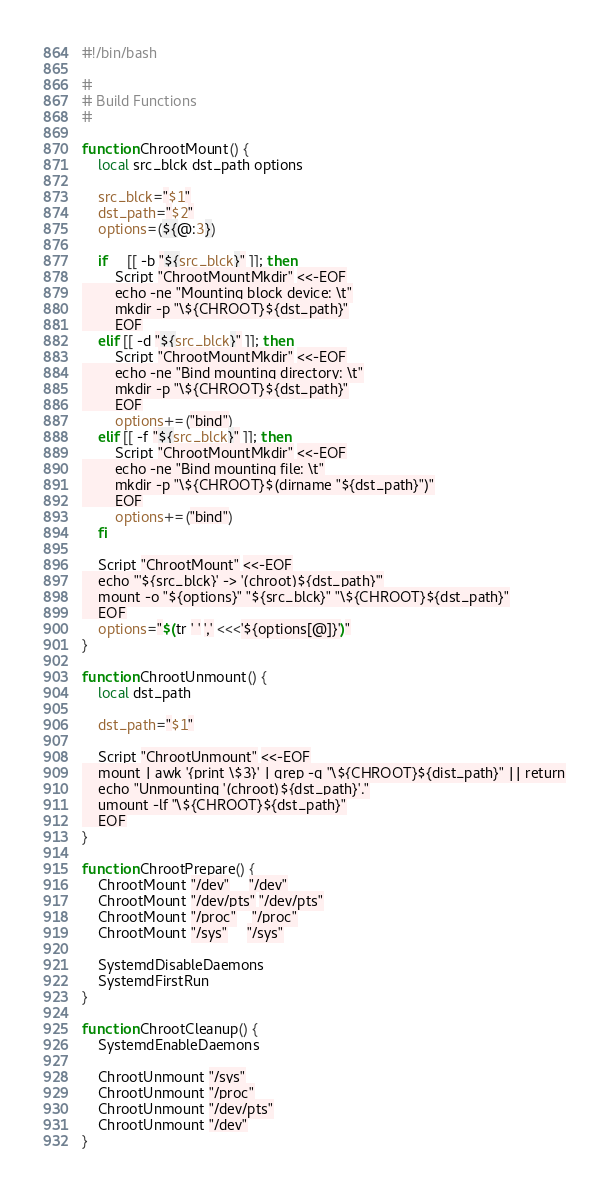<code> <loc_0><loc_0><loc_500><loc_500><_Bash_>#!/bin/bash

#
# Build Functions
#

function ChrootMount() {
	local src_blck dst_path options

	src_blck="$1"
	dst_path="$2"
	options=(${@:3})

	if	 [[ -b "${src_blck}" ]]; then
		Script "ChrootMountMkdir" <<-EOF
		echo -ne "Mounting block device: \t"
		mkdir -p "\${CHROOT}${dst_path}"
		EOF
	elif [[ -d "${src_blck}" ]]; then
		Script "ChrootMountMkdir" <<-EOF
		echo -ne "Bind mounting directory: \t"
		mkdir -p "\${CHROOT}${dst_path}"
		EOF
		options+=("bind")
	elif [[ -f "${src_blck}" ]]; then
		Script "ChrootMountMkdir" <<-EOF
		echo -ne "Bind mounting file: \t"
		mkdir -p "\${CHROOT}$(dirname "${dst_path}")"
		EOF
		options+=("bind")
	fi

	Script "ChrootMount" <<-EOF
	echo "'${src_blck}' -> '(chroot)${dst_path}'"
	mount -o "${options}" "${src_blck}" "\${CHROOT}${dst_path}"
	EOF
	options="$(tr ' ' ',' <<<'${options[@]}')"
}

function ChrootUnmount() {
	local dst_path

	dst_path="$1"

	Script "ChrootUnmount" <<-EOF
	mount | awk '{print \$3}' | grep -q "\${CHROOT}${dist_path}" || return
	echo "Unmounting '(chroot)${dst_path}'."
	umount -lf "\${CHROOT}${dst_path}"
	EOF
}

function ChrootPrepare() {
	ChrootMount "/dev"     "/dev"
	ChrootMount "/dev/pts" "/dev/pts"
	ChrootMount "/proc"    "/proc"
	ChrootMount "/sys"     "/sys"

	SystemdDisableDaemons
	SystemdFirstRun
}

function ChrootCleanup() {
	SystemdEnableDaemons

	ChrootUnmount "/sys"
	ChrootUnmount "/proc"
	ChrootUnmount "/dev/pts"
	ChrootUnmount "/dev"
}
</code> 